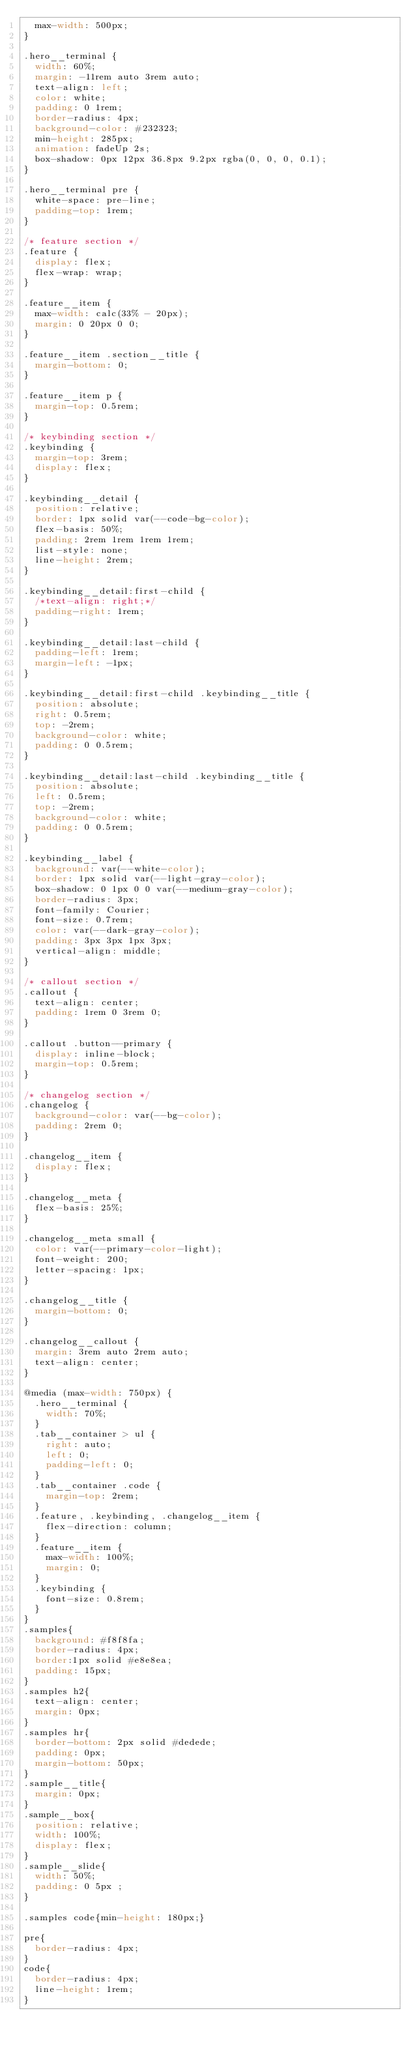Convert code to text. <code><loc_0><loc_0><loc_500><loc_500><_CSS_>  max-width: 500px;
}

.hero__terminal {
  width: 60%;
  margin: -11rem auto 3rem auto;
  text-align: left;
  color: white;
  padding: 0 1rem;
  border-radius: 4px;
  background-color: #232323;
  min-height: 285px;
  animation: fadeUp 2s;
  box-shadow: 0px 12px 36.8px 9.2px rgba(0, 0, 0, 0.1);
}

.hero__terminal pre {
  white-space: pre-line;
  padding-top: 1rem;
}

/* feature section */
.feature {
  display: flex;
  flex-wrap: wrap;
}

.feature__item {
  max-width: calc(33% - 20px);
  margin: 0 20px 0 0;
}

.feature__item .section__title {
  margin-bottom: 0;
}

.feature__item p {
  margin-top: 0.5rem;
}

/* keybinding section */
.keybinding {
  margin-top: 3rem;
  display: flex;
}

.keybinding__detail {
  position: relative;
  border: 1px solid var(--code-bg-color);
  flex-basis: 50%;
  padding: 2rem 1rem 1rem 1rem;
  list-style: none;
  line-height: 2rem;
}

.keybinding__detail:first-child {
  /*text-align: right;*/
  padding-right: 1rem;
}

.keybinding__detail:last-child {
  padding-left: 1rem;
  margin-left: -1px;
}

.keybinding__detail:first-child .keybinding__title {
  position: absolute;
  right: 0.5rem;
  top: -2rem;
  background-color: white;
  padding: 0 0.5rem;
}

.keybinding__detail:last-child .keybinding__title {
  position: absolute;
  left: 0.5rem;
  top: -2rem;
  background-color: white;
  padding: 0 0.5rem;
}

.keybinding__label {
  background: var(--white-color);
  border: 1px solid var(--light-gray-color);
  box-shadow: 0 1px 0 0 var(--medium-gray-color);
  border-radius: 3px;
  font-family: Courier;
  font-size: 0.7rem;
  color: var(--dark-gray-color);
  padding: 3px 3px 1px 3px;
  vertical-align: middle;
}

/* callout section */
.callout {
  text-align: center;
  padding: 1rem 0 3rem 0;
}

.callout .button--primary {
  display: inline-block;
  margin-top: 0.5rem;
}

/* changelog section */
.changelog {
  background-color: var(--bg-color);
  padding: 2rem 0;
}

.changelog__item {
  display: flex;
}

.changelog__meta {
  flex-basis: 25%;
}

.changelog__meta small {
  color: var(--primary-color-light);
  font-weight: 200;
  letter-spacing: 1px;
}

.changelog__title {
  margin-bottom: 0;
}

.changelog__callout {
  margin: 3rem auto 2rem auto;
  text-align: center;
}

@media (max-width: 750px) {
  .hero__terminal {
    width: 70%;
  }
  .tab__container > ul {
    right: auto;
    left: 0;
    padding-left: 0;
  }
  .tab__container .code {
    margin-top: 2rem;
  }
  .feature, .keybinding, .changelog__item {
    flex-direction: column;
  }
  .feature__item {
    max-width: 100%;
    margin: 0;
  }
  .keybinding {
    font-size: 0.8rem;
  }
}
.samples{
  background: #f8f8fa;
  border-radius: 4px;
  border:1px solid #e8e8ea;
  padding: 15px;
}
.samples h2{
  text-align: center;
  margin: 0px;
}
.samples hr{
  border-bottom: 2px solid #dedede;
  padding: 0px;
  margin-bottom: 50px;
}
.sample__title{
  margin: 0px;
}
.sample__box{
  position: relative;
  width: 100%;
  display: flex;
}
.sample__slide{
  width: 50%;
  padding: 0 5px ;
}

.samples code{min-height: 180px;}

pre{
  border-radius: 4px;
}
code{
  border-radius: 4px;
  line-height: 1rem;
}</code> 